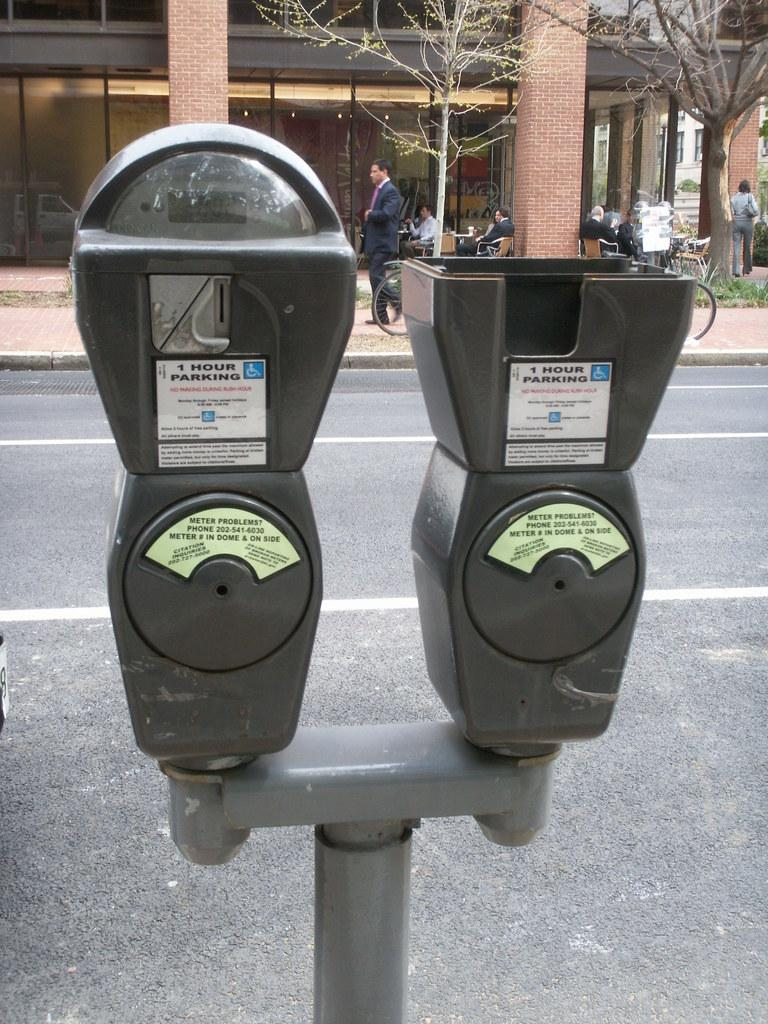<image>
Offer a succinct explanation of the picture presented. a dual parking meter that says 1 hour parking 